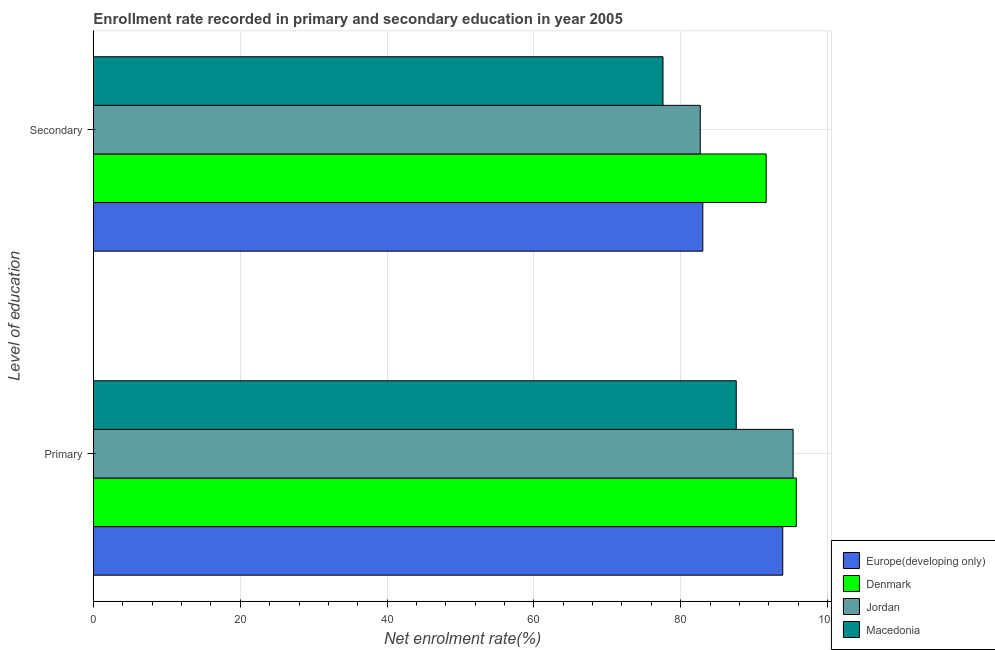How many different coloured bars are there?
Make the answer very short. 4. How many groups of bars are there?
Offer a very short reply. 2. Are the number of bars per tick equal to the number of legend labels?
Offer a very short reply. Yes. Are the number of bars on each tick of the Y-axis equal?
Offer a very short reply. Yes. How many bars are there on the 1st tick from the top?
Provide a short and direct response. 4. How many bars are there on the 2nd tick from the bottom?
Offer a terse response. 4. What is the label of the 1st group of bars from the top?
Offer a very short reply. Secondary. What is the enrollment rate in primary education in Macedonia?
Provide a short and direct response. 87.57. Across all countries, what is the maximum enrollment rate in primary education?
Provide a succinct answer. 95.74. Across all countries, what is the minimum enrollment rate in primary education?
Your response must be concise. 87.57. In which country was the enrollment rate in primary education minimum?
Your answer should be very brief. Macedonia. What is the total enrollment rate in secondary education in the graph?
Offer a terse response. 334.9. What is the difference between the enrollment rate in primary education in Jordan and that in Denmark?
Offer a very short reply. -0.43. What is the difference between the enrollment rate in primary education in Macedonia and the enrollment rate in secondary education in Jordan?
Ensure brevity in your answer.  4.9. What is the average enrollment rate in primary education per country?
Your answer should be compact. 93.13. What is the difference between the enrollment rate in secondary education and enrollment rate in primary education in Jordan?
Provide a succinct answer. -12.65. What is the ratio of the enrollment rate in primary education in Macedonia to that in Jordan?
Your answer should be very brief. 0.92. Is the enrollment rate in primary education in Denmark less than that in Jordan?
Offer a very short reply. No. In how many countries, is the enrollment rate in primary education greater than the average enrollment rate in primary education taken over all countries?
Give a very brief answer. 3. What does the 4th bar from the top in Secondary represents?
Your answer should be compact. Europe(developing only). What does the 2nd bar from the bottom in Secondary represents?
Keep it short and to the point. Denmark. How many bars are there?
Keep it short and to the point. 8. Are all the bars in the graph horizontal?
Keep it short and to the point. Yes. What is the difference between two consecutive major ticks on the X-axis?
Give a very brief answer. 20. Does the graph contain any zero values?
Your answer should be very brief. No. Does the graph contain grids?
Keep it short and to the point. Yes. Where does the legend appear in the graph?
Your response must be concise. Bottom right. How many legend labels are there?
Provide a succinct answer. 4. How are the legend labels stacked?
Make the answer very short. Vertical. What is the title of the graph?
Your response must be concise. Enrollment rate recorded in primary and secondary education in year 2005. Does "Zambia" appear as one of the legend labels in the graph?
Your response must be concise. No. What is the label or title of the X-axis?
Give a very brief answer. Net enrolment rate(%). What is the label or title of the Y-axis?
Provide a short and direct response. Level of education. What is the Net enrolment rate(%) of Europe(developing only) in Primary?
Offer a terse response. 93.9. What is the Net enrolment rate(%) of Denmark in Primary?
Your response must be concise. 95.74. What is the Net enrolment rate(%) in Jordan in Primary?
Keep it short and to the point. 95.32. What is the Net enrolment rate(%) of Macedonia in Primary?
Your answer should be very brief. 87.57. What is the Net enrolment rate(%) in Europe(developing only) in Secondary?
Give a very brief answer. 83.01. What is the Net enrolment rate(%) of Denmark in Secondary?
Offer a terse response. 91.64. What is the Net enrolment rate(%) of Jordan in Secondary?
Ensure brevity in your answer.  82.66. What is the Net enrolment rate(%) in Macedonia in Secondary?
Ensure brevity in your answer.  77.59. Across all Level of education, what is the maximum Net enrolment rate(%) in Europe(developing only)?
Your answer should be very brief. 93.9. Across all Level of education, what is the maximum Net enrolment rate(%) of Denmark?
Ensure brevity in your answer.  95.74. Across all Level of education, what is the maximum Net enrolment rate(%) in Jordan?
Your answer should be compact. 95.32. Across all Level of education, what is the maximum Net enrolment rate(%) of Macedonia?
Make the answer very short. 87.57. Across all Level of education, what is the minimum Net enrolment rate(%) of Europe(developing only)?
Keep it short and to the point. 83.01. Across all Level of education, what is the minimum Net enrolment rate(%) in Denmark?
Your response must be concise. 91.64. Across all Level of education, what is the minimum Net enrolment rate(%) in Jordan?
Offer a terse response. 82.66. Across all Level of education, what is the minimum Net enrolment rate(%) in Macedonia?
Ensure brevity in your answer.  77.59. What is the total Net enrolment rate(%) in Europe(developing only) in the graph?
Your answer should be compact. 176.91. What is the total Net enrolment rate(%) in Denmark in the graph?
Keep it short and to the point. 187.39. What is the total Net enrolment rate(%) in Jordan in the graph?
Offer a very short reply. 177.98. What is the total Net enrolment rate(%) in Macedonia in the graph?
Give a very brief answer. 165.15. What is the difference between the Net enrolment rate(%) in Europe(developing only) in Primary and that in Secondary?
Offer a terse response. 10.89. What is the difference between the Net enrolment rate(%) of Denmark in Primary and that in Secondary?
Your response must be concise. 4.1. What is the difference between the Net enrolment rate(%) in Jordan in Primary and that in Secondary?
Your answer should be very brief. 12.65. What is the difference between the Net enrolment rate(%) of Macedonia in Primary and that in Secondary?
Provide a short and direct response. 9.98. What is the difference between the Net enrolment rate(%) in Europe(developing only) in Primary and the Net enrolment rate(%) in Denmark in Secondary?
Ensure brevity in your answer.  2.26. What is the difference between the Net enrolment rate(%) in Europe(developing only) in Primary and the Net enrolment rate(%) in Jordan in Secondary?
Your answer should be very brief. 11.24. What is the difference between the Net enrolment rate(%) of Europe(developing only) in Primary and the Net enrolment rate(%) of Macedonia in Secondary?
Ensure brevity in your answer.  16.32. What is the difference between the Net enrolment rate(%) in Denmark in Primary and the Net enrolment rate(%) in Jordan in Secondary?
Offer a terse response. 13.08. What is the difference between the Net enrolment rate(%) in Denmark in Primary and the Net enrolment rate(%) in Macedonia in Secondary?
Make the answer very short. 18.16. What is the difference between the Net enrolment rate(%) of Jordan in Primary and the Net enrolment rate(%) of Macedonia in Secondary?
Your response must be concise. 17.73. What is the average Net enrolment rate(%) in Europe(developing only) per Level of education?
Your answer should be very brief. 88.46. What is the average Net enrolment rate(%) in Denmark per Level of education?
Make the answer very short. 93.69. What is the average Net enrolment rate(%) of Jordan per Level of education?
Keep it short and to the point. 88.99. What is the average Net enrolment rate(%) in Macedonia per Level of education?
Your response must be concise. 82.58. What is the difference between the Net enrolment rate(%) of Europe(developing only) and Net enrolment rate(%) of Denmark in Primary?
Keep it short and to the point. -1.84. What is the difference between the Net enrolment rate(%) of Europe(developing only) and Net enrolment rate(%) of Jordan in Primary?
Give a very brief answer. -1.41. What is the difference between the Net enrolment rate(%) in Europe(developing only) and Net enrolment rate(%) in Macedonia in Primary?
Give a very brief answer. 6.34. What is the difference between the Net enrolment rate(%) in Denmark and Net enrolment rate(%) in Jordan in Primary?
Give a very brief answer. 0.43. What is the difference between the Net enrolment rate(%) in Denmark and Net enrolment rate(%) in Macedonia in Primary?
Provide a short and direct response. 8.18. What is the difference between the Net enrolment rate(%) of Jordan and Net enrolment rate(%) of Macedonia in Primary?
Provide a succinct answer. 7.75. What is the difference between the Net enrolment rate(%) in Europe(developing only) and Net enrolment rate(%) in Denmark in Secondary?
Provide a succinct answer. -8.63. What is the difference between the Net enrolment rate(%) in Europe(developing only) and Net enrolment rate(%) in Jordan in Secondary?
Keep it short and to the point. 0.35. What is the difference between the Net enrolment rate(%) in Europe(developing only) and Net enrolment rate(%) in Macedonia in Secondary?
Keep it short and to the point. 5.43. What is the difference between the Net enrolment rate(%) in Denmark and Net enrolment rate(%) in Jordan in Secondary?
Your answer should be compact. 8.98. What is the difference between the Net enrolment rate(%) of Denmark and Net enrolment rate(%) of Macedonia in Secondary?
Your answer should be very brief. 14.06. What is the difference between the Net enrolment rate(%) in Jordan and Net enrolment rate(%) in Macedonia in Secondary?
Offer a very short reply. 5.08. What is the ratio of the Net enrolment rate(%) of Europe(developing only) in Primary to that in Secondary?
Your answer should be compact. 1.13. What is the ratio of the Net enrolment rate(%) in Denmark in Primary to that in Secondary?
Make the answer very short. 1.04. What is the ratio of the Net enrolment rate(%) of Jordan in Primary to that in Secondary?
Your answer should be very brief. 1.15. What is the ratio of the Net enrolment rate(%) of Macedonia in Primary to that in Secondary?
Ensure brevity in your answer.  1.13. What is the difference between the highest and the second highest Net enrolment rate(%) of Europe(developing only)?
Provide a succinct answer. 10.89. What is the difference between the highest and the second highest Net enrolment rate(%) in Denmark?
Provide a short and direct response. 4.1. What is the difference between the highest and the second highest Net enrolment rate(%) in Jordan?
Your answer should be very brief. 12.65. What is the difference between the highest and the second highest Net enrolment rate(%) of Macedonia?
Make the answer very short. 9.98. What is the difference between the highest and the lowest Net enrolment rate(%) in Europe(developing only)?
Provide a short and direct response. 10.89. What is the difference between the highest and the lowest Net enrolment rate(%) of Denmark?
Ensure brevity in your answer.  4.1. What is the difference between the highest and the lowest Net enrolment rate(%) in Jordan?
Offer a very short reply. 12.65. What is the difference between the highest and the lowest Net enrolment rate(%) in Macedonia?
Offer a terse response. 9.98. 